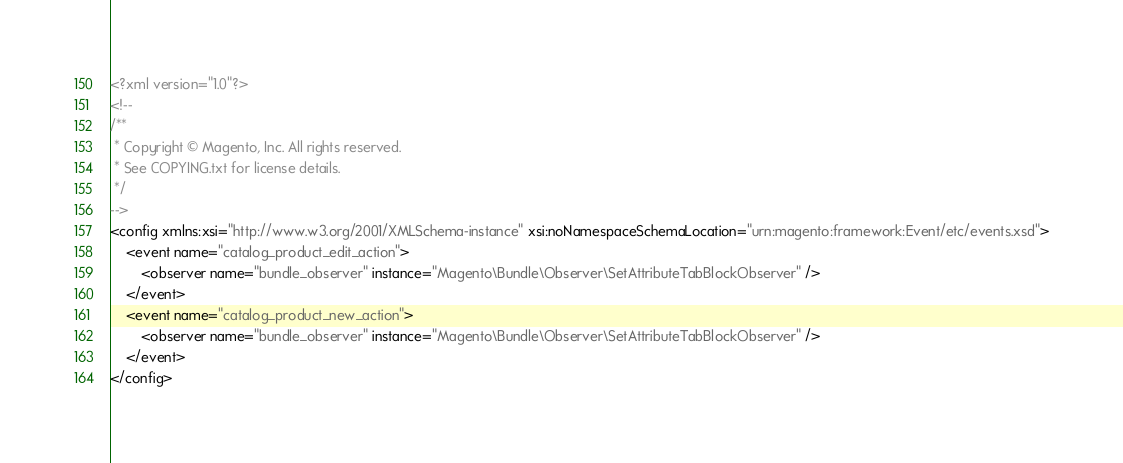Convert code to text. <code><loc_0><loc_0><loc_500><loc_500><_XML_><?xml version="1.0"?>
<!--
/**
 * Copyright © Magento, Inc. All rights reserved.
 * See COPYING.txt for license details.
 */
-->
<config xmlns:xsi="http://www.w3.org/2001/XMLSchema-instance" xsi:noNamespaceSchemaLocation="urn:magento:framework:Event/etc/events.xsd">
    <event name="catalog_product_edit_action">
        <observer name="bundle_observer" instance="Magento\Bundle\Observer\SetAttributeTabBlockObserver" />
    </event>
    <event name="catalog_product_new_action">
        <observer name="bundle_observer" instance="Magento\Bundle\Observer\SetAttributeTabBlockObserver" />
    </event>
</config>
</code> 